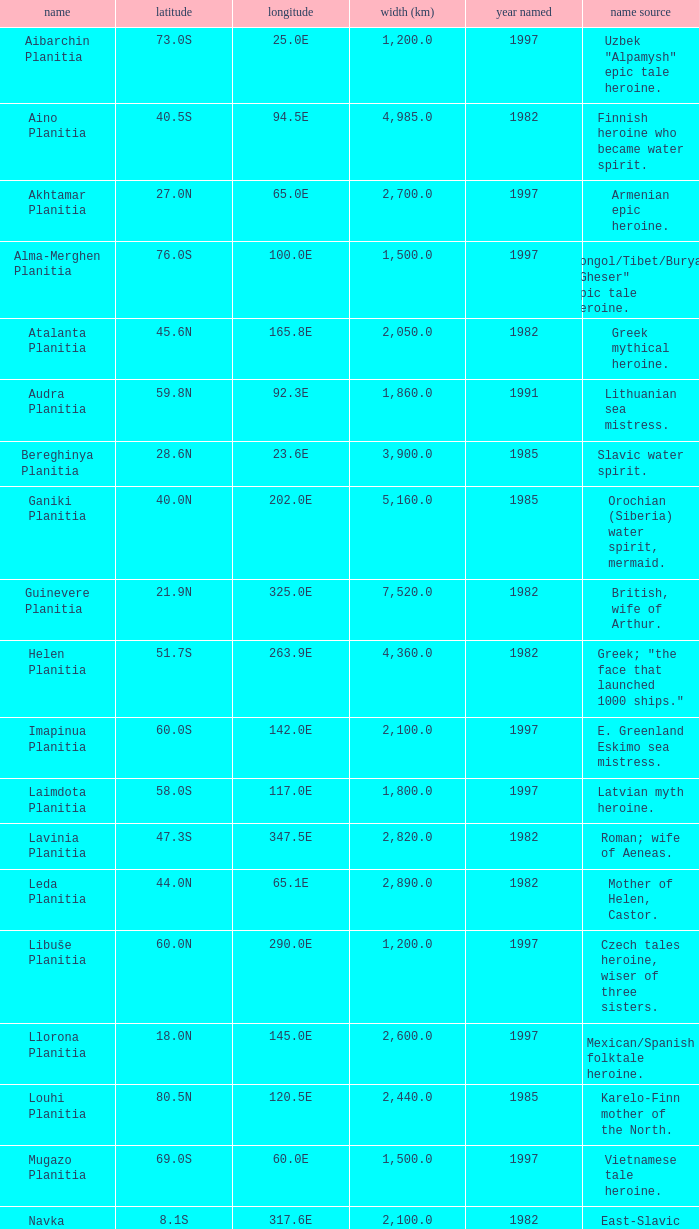What's the name origin of feature of diameter (km) 2,155.0 Karelo-Finn mermaid. 